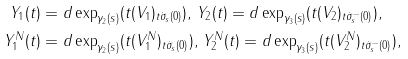<formula> <loc_0><loc_0><loc_500><loc_500>Y _ { 1 } ( t ) & = d \exp _ { \gamma _ { 2 } ( s ) } ( t ( V _ { 1 } ) _ { t \dot { \sigma } _ { s } ( 0 ) } ) , \, Y _ { 2 } ( t ) = d \exp _ { \gamma _ { 3 } ( s ) } ( t ( V _ { 2 } ) _ { t \dot { \sigma } _ { s } ^ { - } ( 0 ) } ) , \\ Y _ { 1 } ^ { N } ( t ) & = d \exp _ { \gamma _ { 2 } ( s ) } ( t ( V _ { 1 } ^ { N } ) _ { t \dot { \sigma } _ { s } ( 0 ) } ) , \, Y _ { 2 } ^ { N } ( t ) = d \exp _ { \gamma _ { 3 } ( s ) } ( t ( V _ { 2 } ^ { N } ) _ { t \dot { \sigma } _ { s } ^ { - } ( 0 ) } ) ,</formula> 